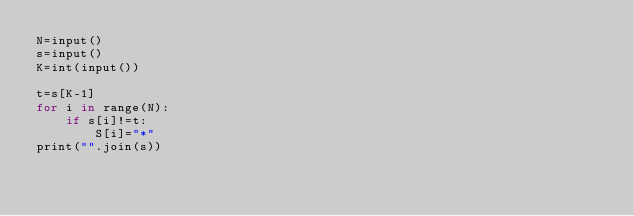Convert code to text. <code><loc_0><loc_0><loc_500><loc_500><_Ruby_>N=input()
s=input()
K=int(input())

t=s[K-1]
for i in range(N):
    if s[i]!=t:
        S[i]="*"
print("".join(s))
</code> 